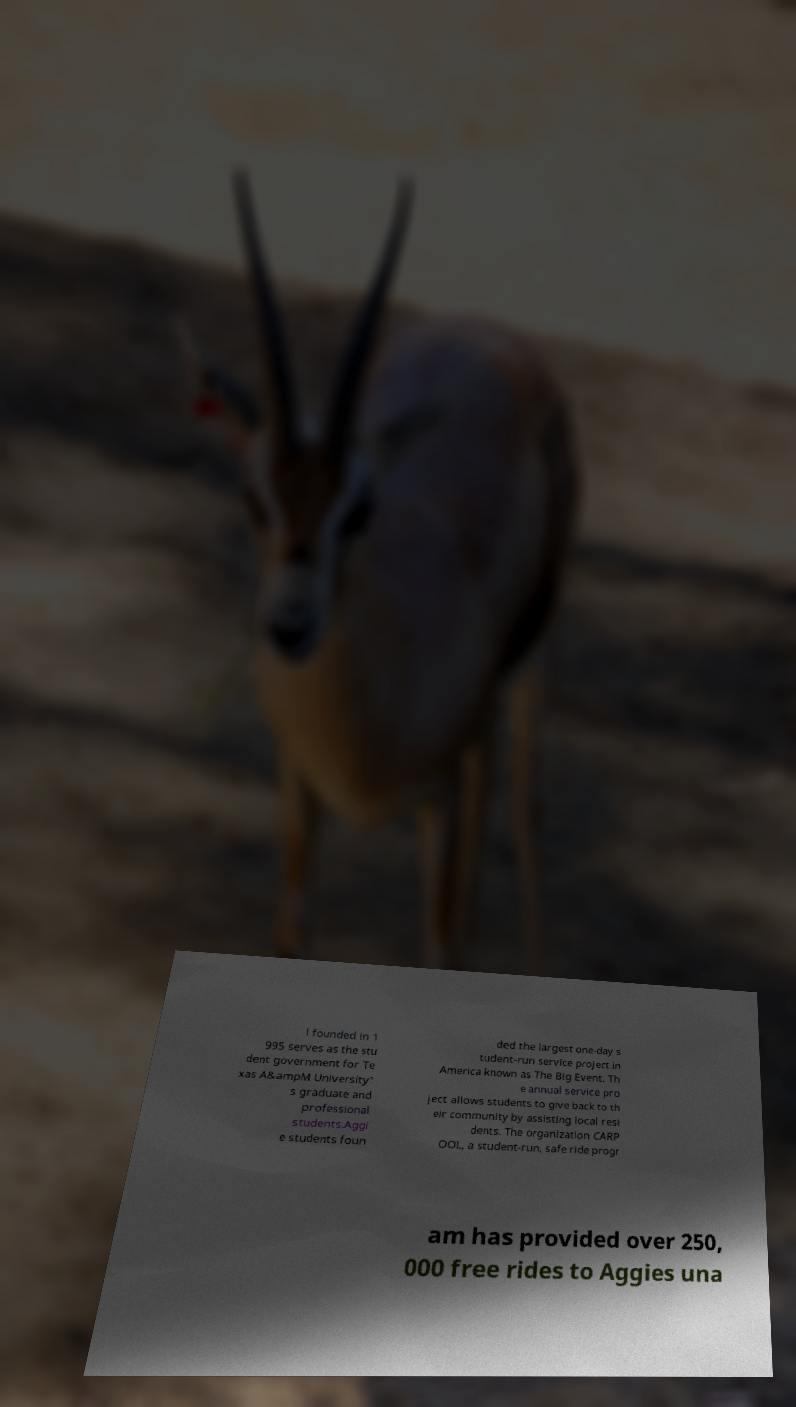Please identify and transcribe the text found in this image. l founded in 1 995 serves as the stu dent government for Te xas A&ampM University' s graduate and professional students.Aggi e students foun ded the largest one-day s tudent-run service project in America known as The Big Event. Th e annual service pro ject allows students to give back to th eir community by assisting local resi dents. The organization CARP OOL, a student-run, safe ride progr am has provided over 250, 000 free rides to Aggies una 